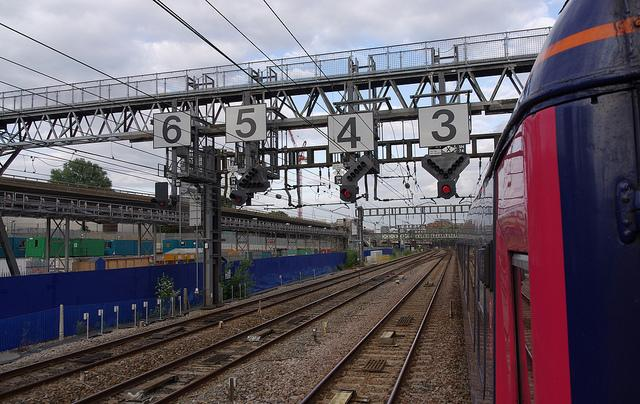What is the next number in the sequence? two 